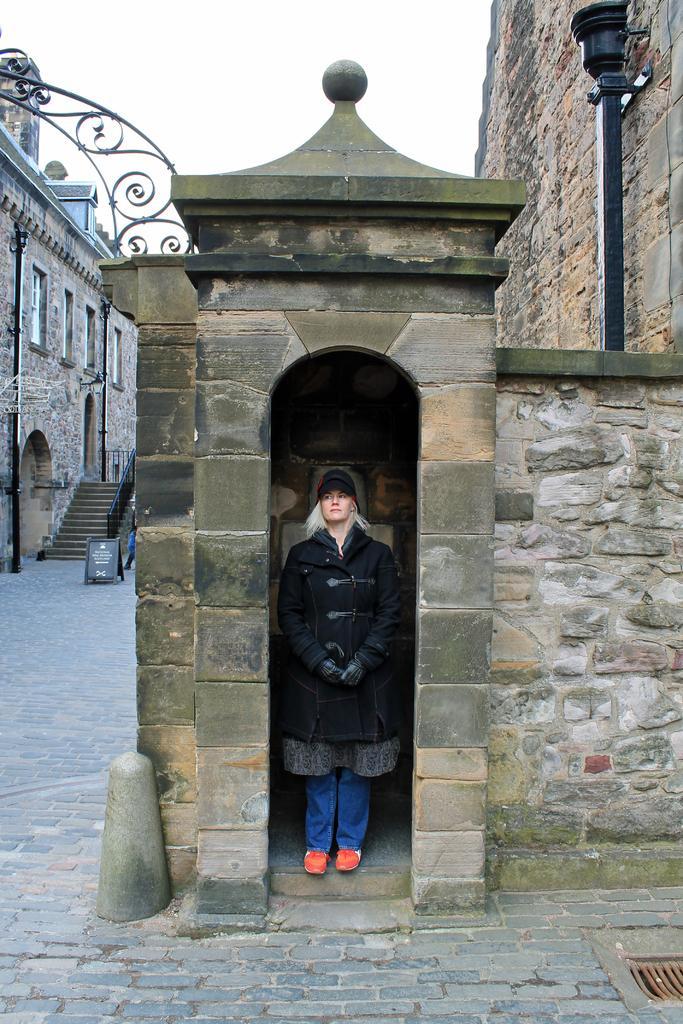Please provide a concise description of this image. In this image we can see a woman wearing a black dress and a cap is standing inside an arch of a building. In the background, we can see a staircase and a building with windows and a sign board placed on the ground and the sky. 